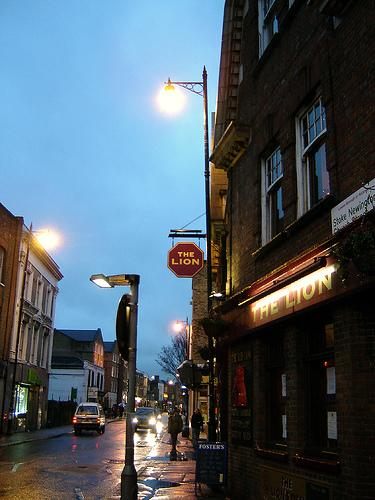Which sign will be easier for someone way down the street to spot? Please explain your reasoning. octagon. The sign easier to see would be the sign for "the lion" that is shaped like a stop sign with eight sides. 